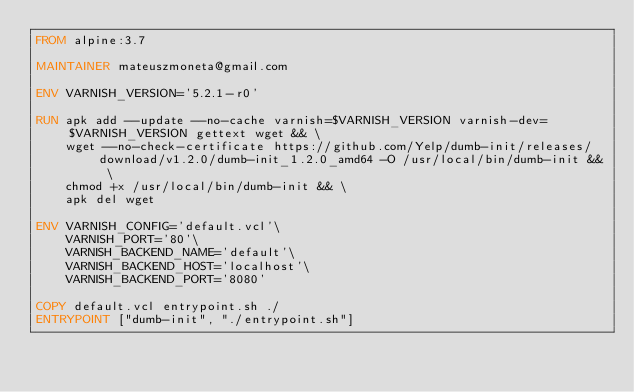Convert code to text. <code><loc_0><loc_0><loc_500><loc_500><_Dockerfile_>FROM alpine:3.7

MAINTAINER mateuszmoneta@gmail.com

ENV VARNISH_VERSION='5.2.1-r0'

RUN apk add --update --no-cache varnish=$VARNISH_VERSION varnish-dev=$VARNISH_VERSION gettext wget && \
    wget --no-check-certificate https://github.com/Yelp/dumb-init/releases/download/v1.2.0/dumb-init_1.2.0_amd64 -O /usr/local/bin/dumb-init && \
    chmod +x /usr/local/bin/dumb-init && \
    apk del wget

ENV VARNISH_CONFIG='default.vcl'\
    VARNISH_PORT='80'\
    VARNISH_BACKEND_NAME='default'\
    VARNISH_BACKEND_HOST='localhost'\
    VARNISH_BACKEND_PORT='8080'

COPY default.vcl entrypoint.sh ./
ENTRYPOINT ["dumb-init", "./entrypoint.sh"]
</code> 